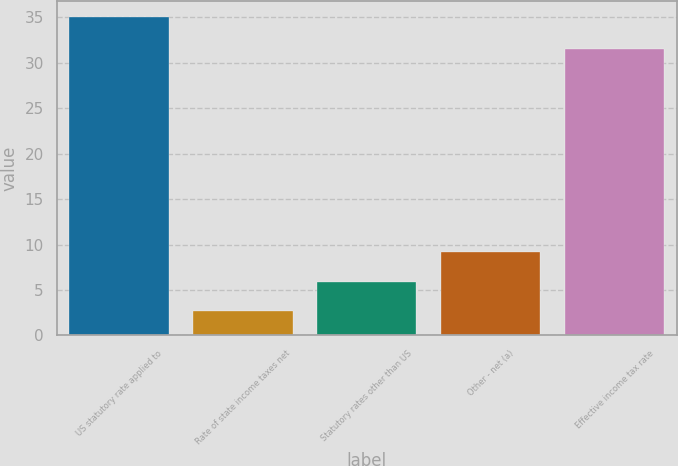Convert chart to OTSL. <chart><loc_0><loc_0><loc_500><loc_500><bar_chart><fcel>US statutory rate applied to<fcel>Rate of state income taxes net<fcel>Statutory rates other than US<fcel>Other - net (a)<fcel>Effective income tax rate<nl><fcel>35<fcel>2.7<fcel>5.93<fcel>9.16<fcel>31.5<nl></chart> 